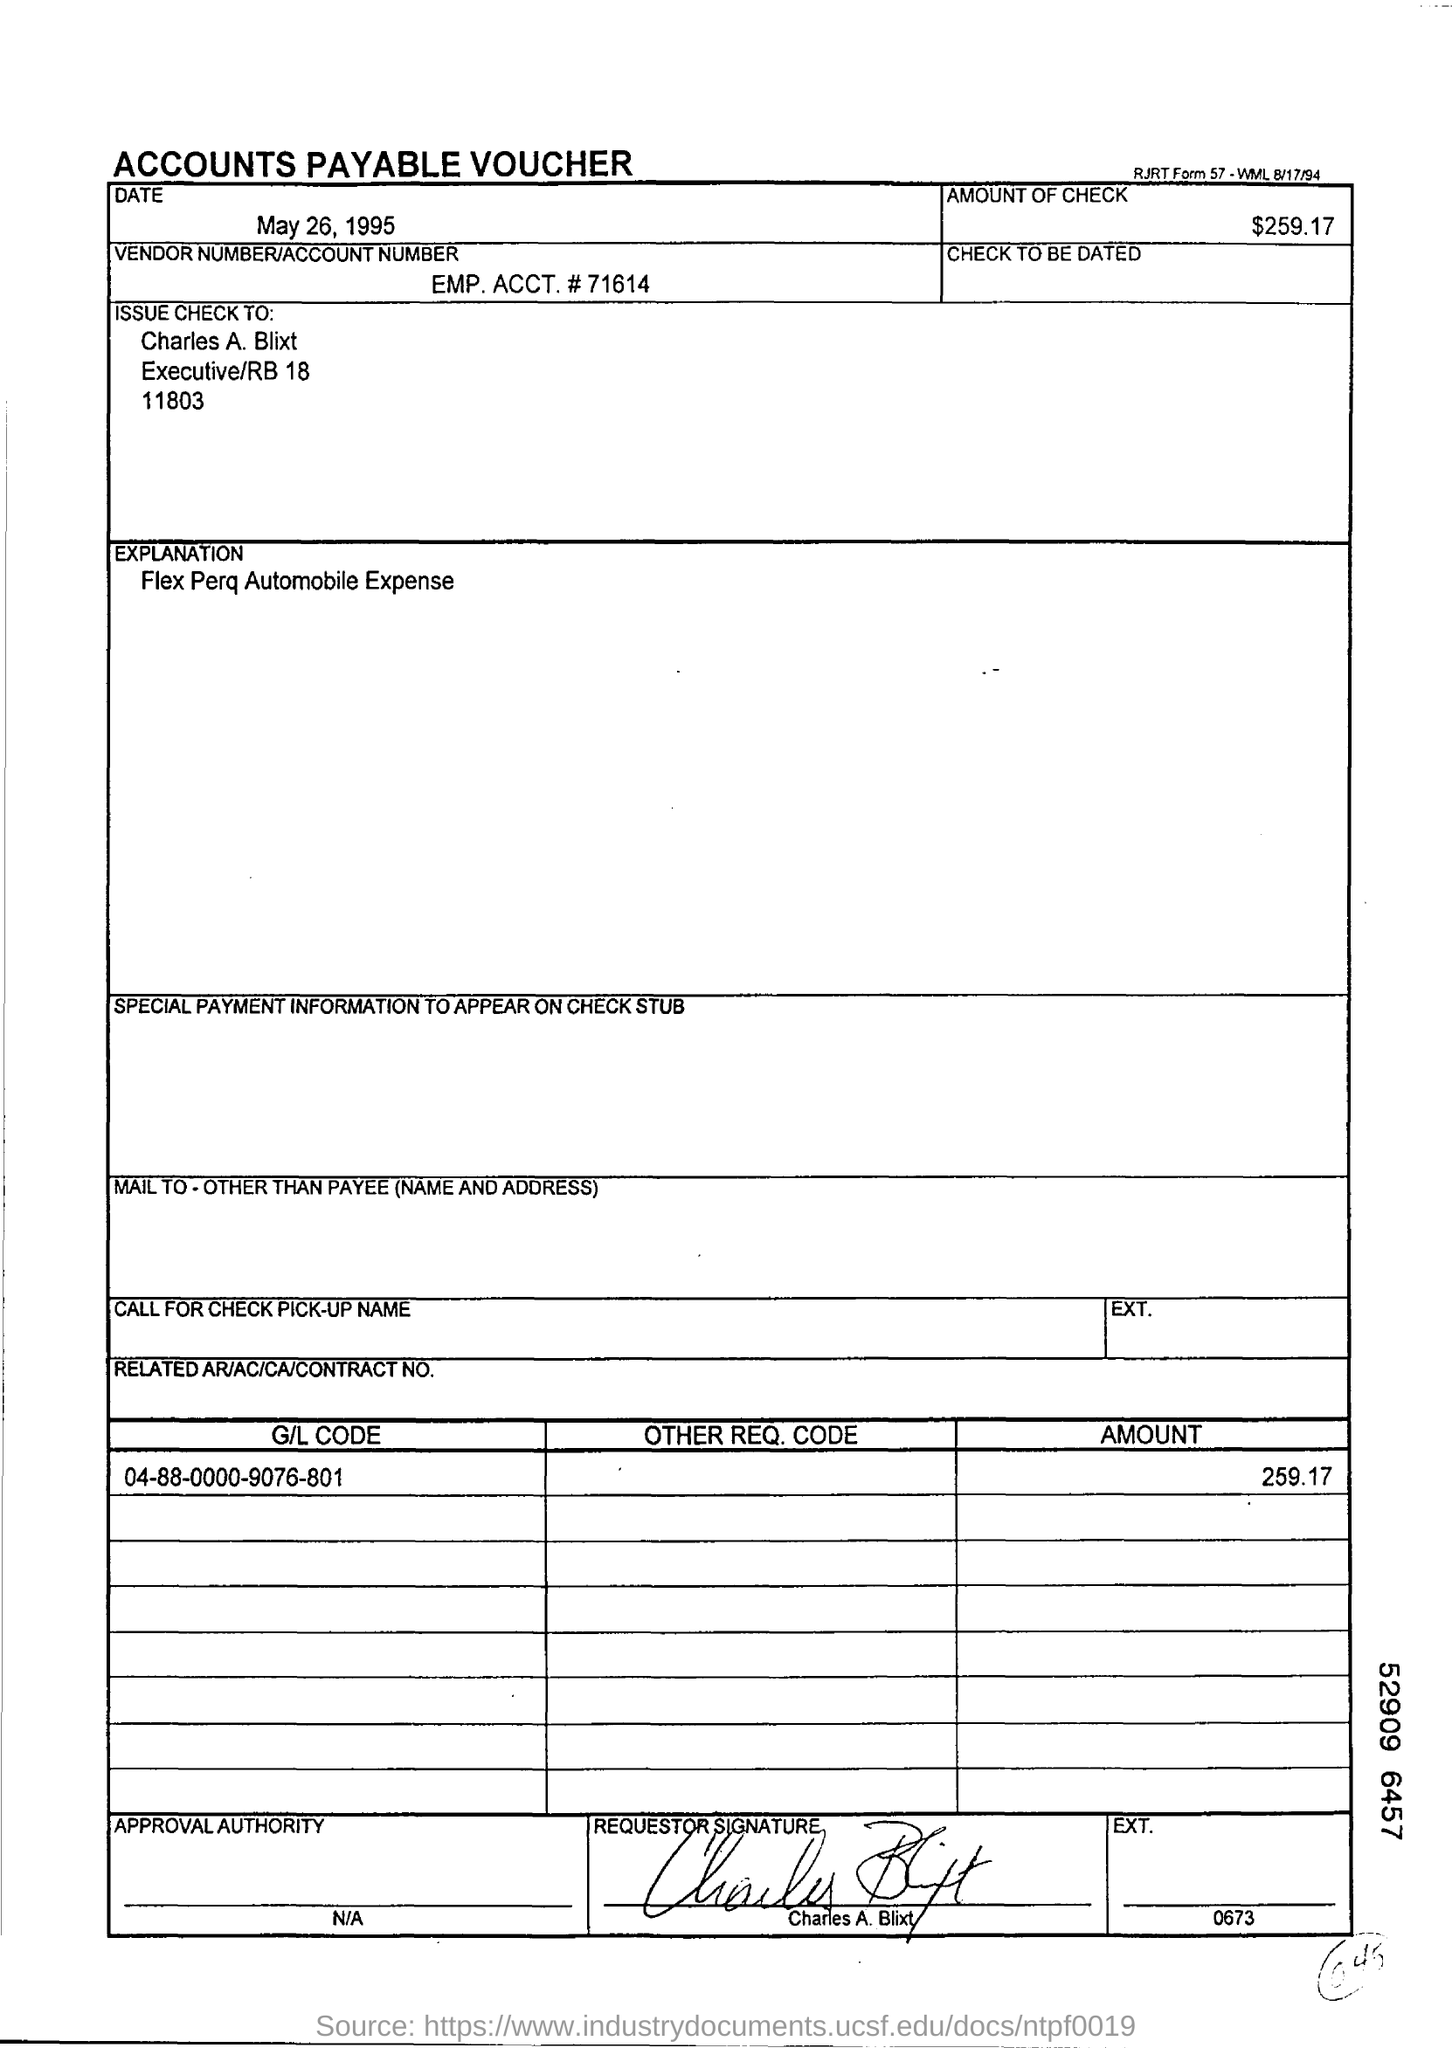Identify some key points in this picture. The person to whom the check should be issued is Charles A. Blixt. The document is dated May 26, 1995. The G/L code mentioned is 04-88-0000-9076-801. What is the explanation given for the Flex Perq Automobile Expense? The vendor number/account number is EMP. ACCT. # 71614. 